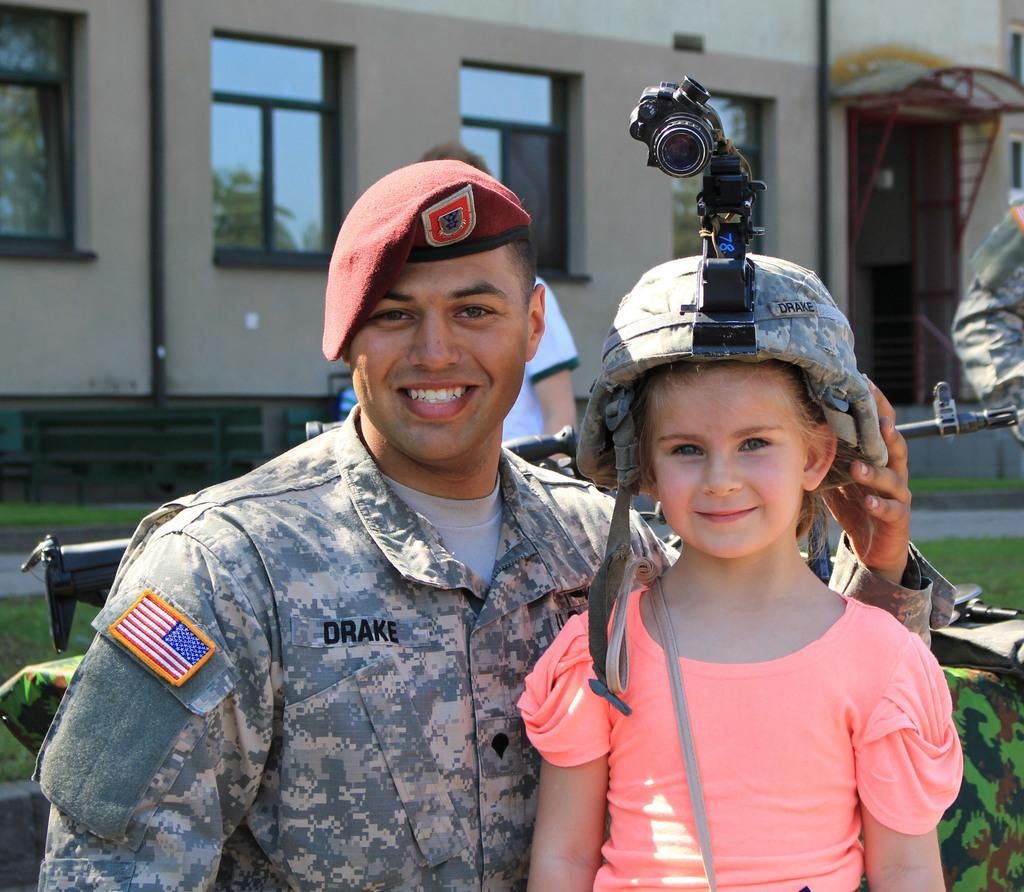Who can be seen in the image? There is a man and a girl in the image. What are the expressions on their faces? Both the man and the girl are smiling. What can be seen in the background of the image? There is a building in the background of the image. What type of friction is present between the man and the girl in the image? There is no indication of friction between the man and the girl in the image; they are both smiling. What hobbies do the man and the girl share, as seen in the image? The image does not provide information about the hobbies of the man and the girl. 